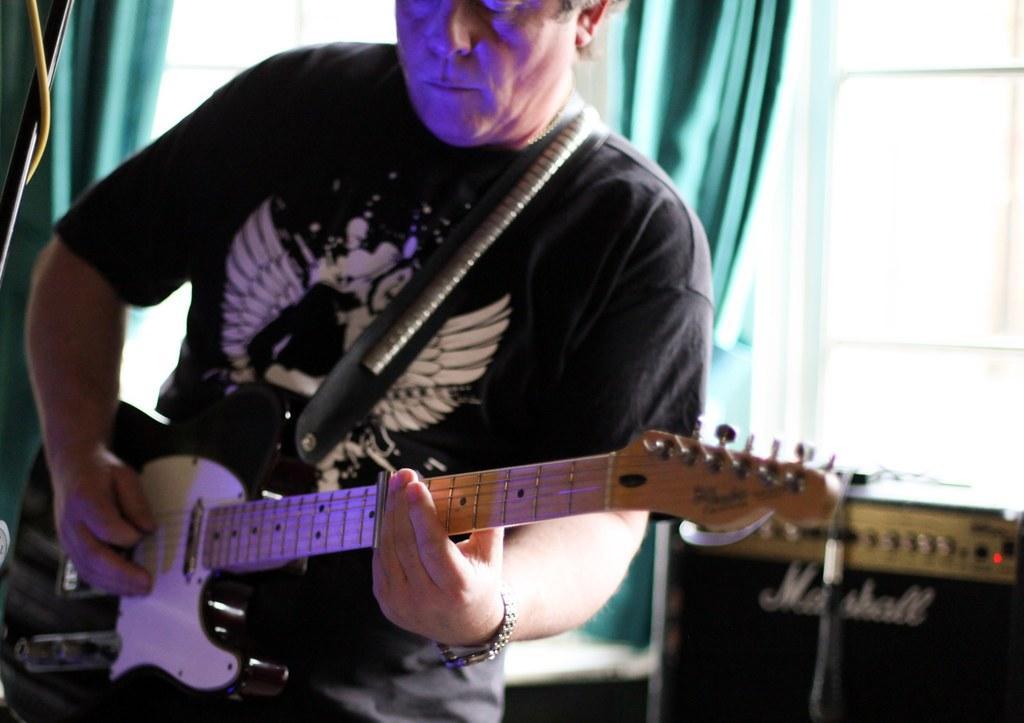Please provide a concise description of this image. This is the picture of a man holding a guitar and playing it and behind him there is a speaker. 